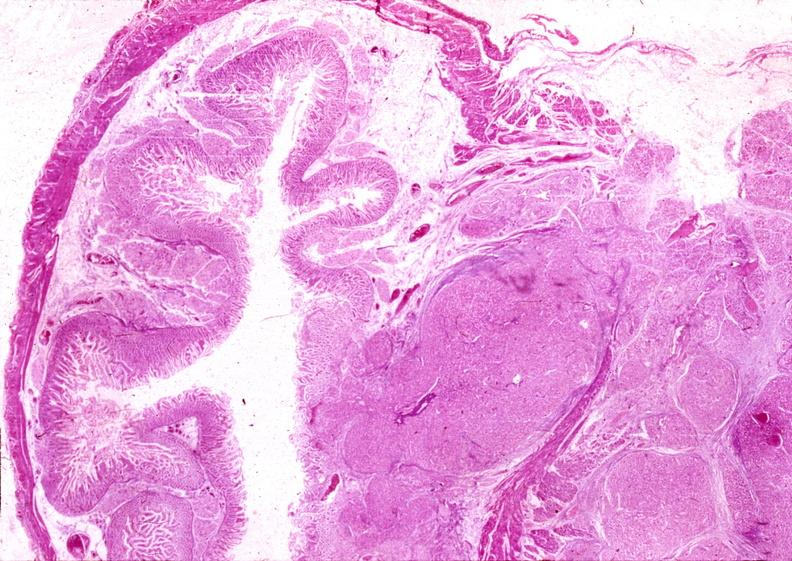s pancreas present?
Answer the question using a single word or phrase. Yes 